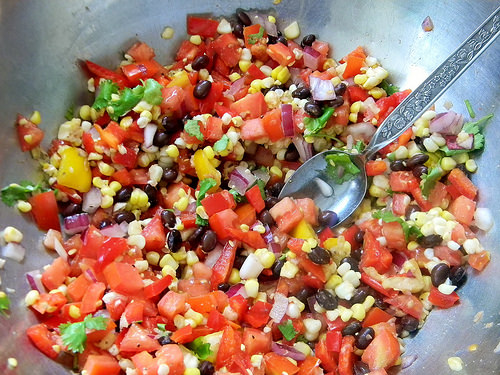<image>
Is there a spoon in front of the salsa? No. The spoon is not in front of the salsa. The spatial positioning shows a different relationship between these objects. 